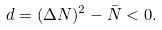Convert formula to latex. <formula><loc_0><loc_0><loc_500><loc_500>d = ( \Delta N ) ^ { 2 } - \bar { N } < 0 .</formula> 